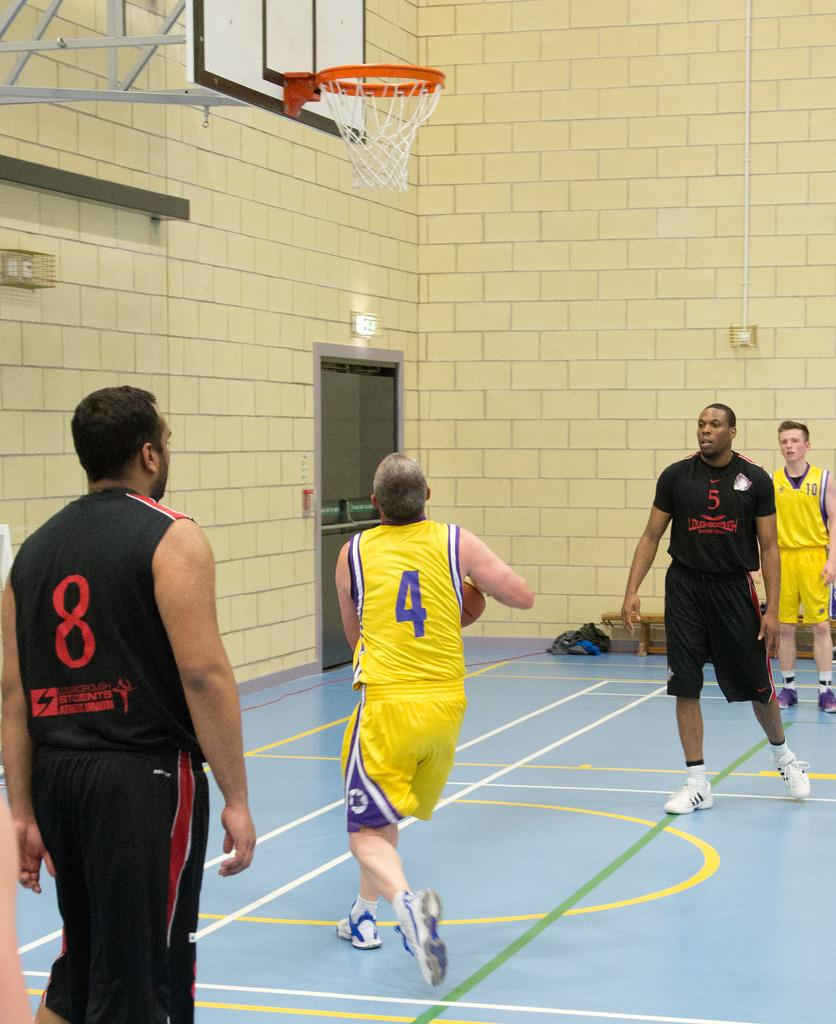<image>
Write a terse but informative summary of the picture. A man with the number 4 jersey attempt to shoot a ball in the hoop. 